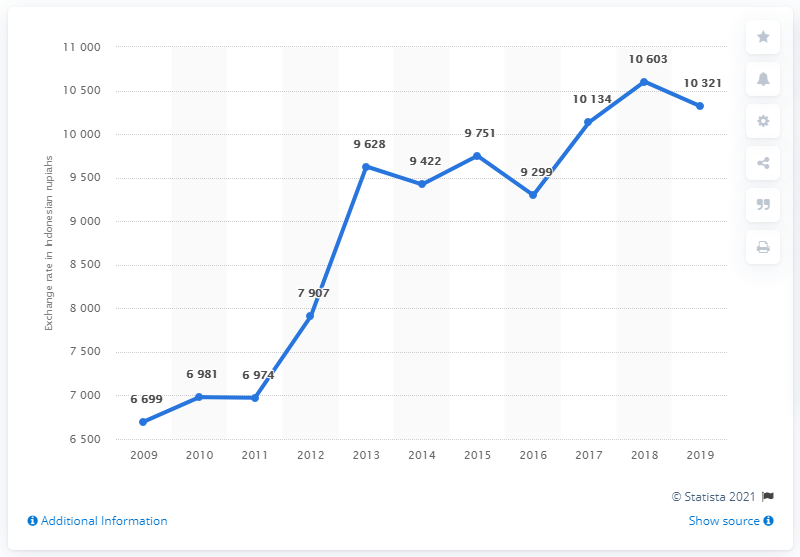Identify some key points in this picture. In 2019, the average exchange rate from Indonesian rupiahs to Singaporean dollars was 103.21. In 2019, the average exchange rate from Indonesian rupiahs to Singaporean dollars was 103.21. 